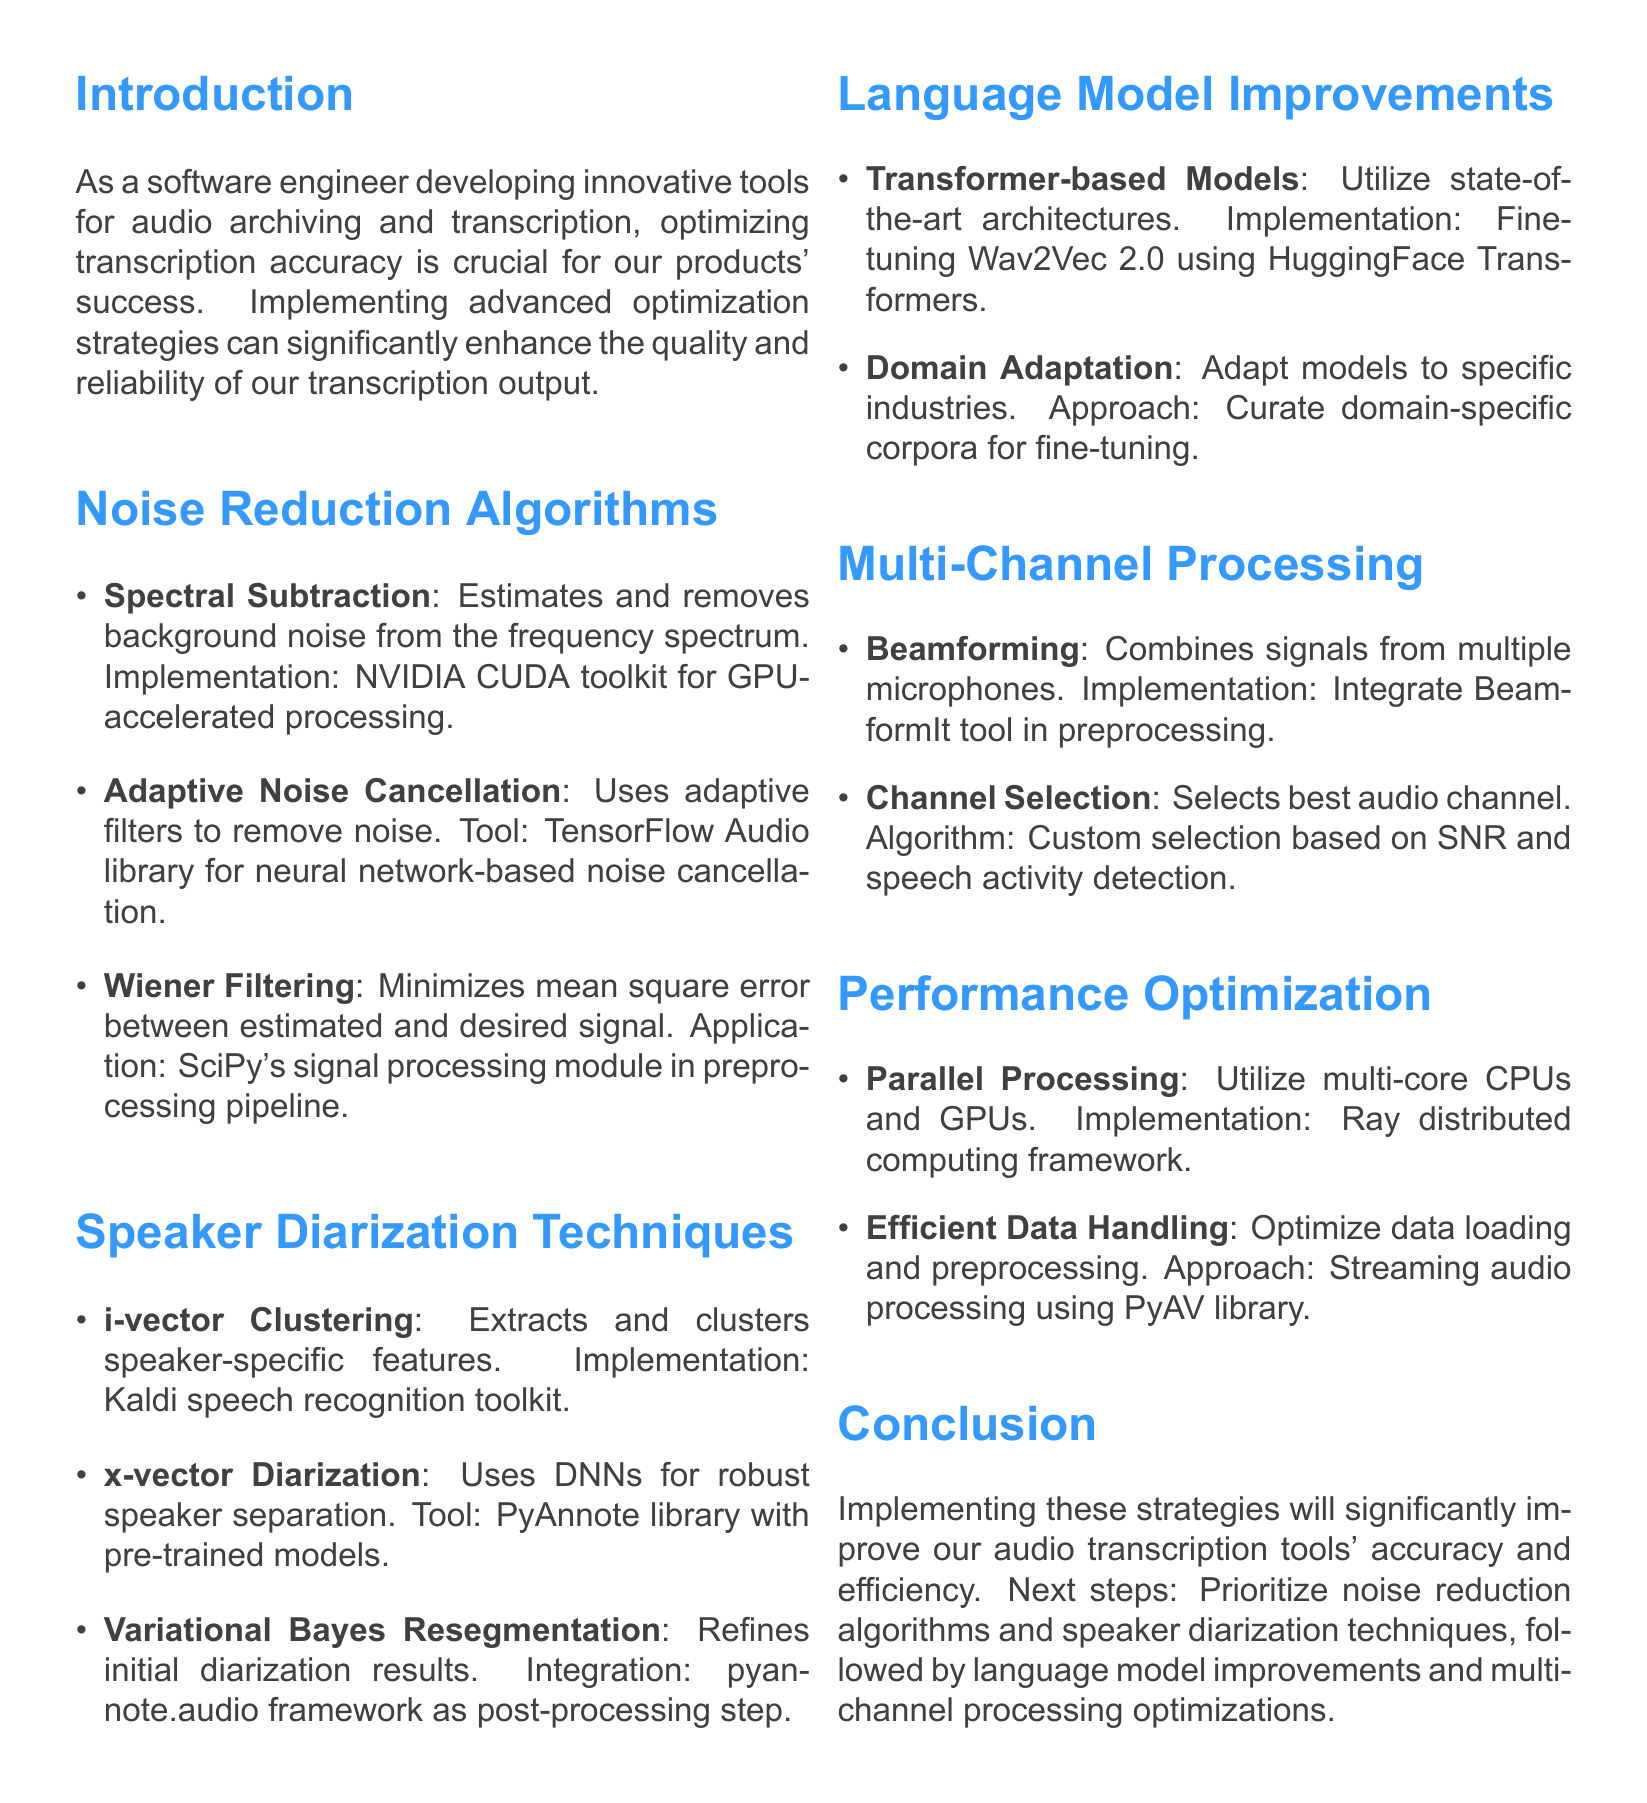What is the main context of the memo? The main context describes the importance of optimizing transcription accuracy for audio archiving and transcription tools.
Answer: Optimizing transcription accuracy What library is suggested for implementing adaptive noise cancellation? The document states that the TensorFlow Audio library is recommended for efficient neural network-based noise cancellation.
Answer: TensorFlow Audio library Which technique utilizes deep neural networks to extract speaker-specific features? The x-vector diarization method is highlighted as using deep neural networks for robust speaker separation.
Answer: x-vector diarization What implementation is suggested for spectral subtraction? NVIDIA CUDA toolkit is mentioned for GPU-accelerated processing of the spectral subtraction technique.
Answer: NVIDIA CUDA toolkit What is the next step prioritized after noise reduction algorithms? The memo outlines that speaker diarization techniques should be prioritized after noise reduction.
Answer: Speaker diarization techniques What technique combines signals from multiple microphones? Beamforming is the technique described for combining signals to enhance desired audio.
Answer: Beamforming How does the memo suggest improving language model accuracy? Adapting general-purpose language models to specific domains is suggested for improved accuracy.
Answer: Domain adaptation Which framework is recommended for parallel processing? The Ray distributed computing framework is recommended for utilizing multi-core CPUs and GPUs.
Answer: Ray distributed computing framework 